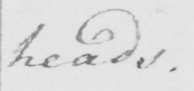What is written in this line of handwriting? heads . 